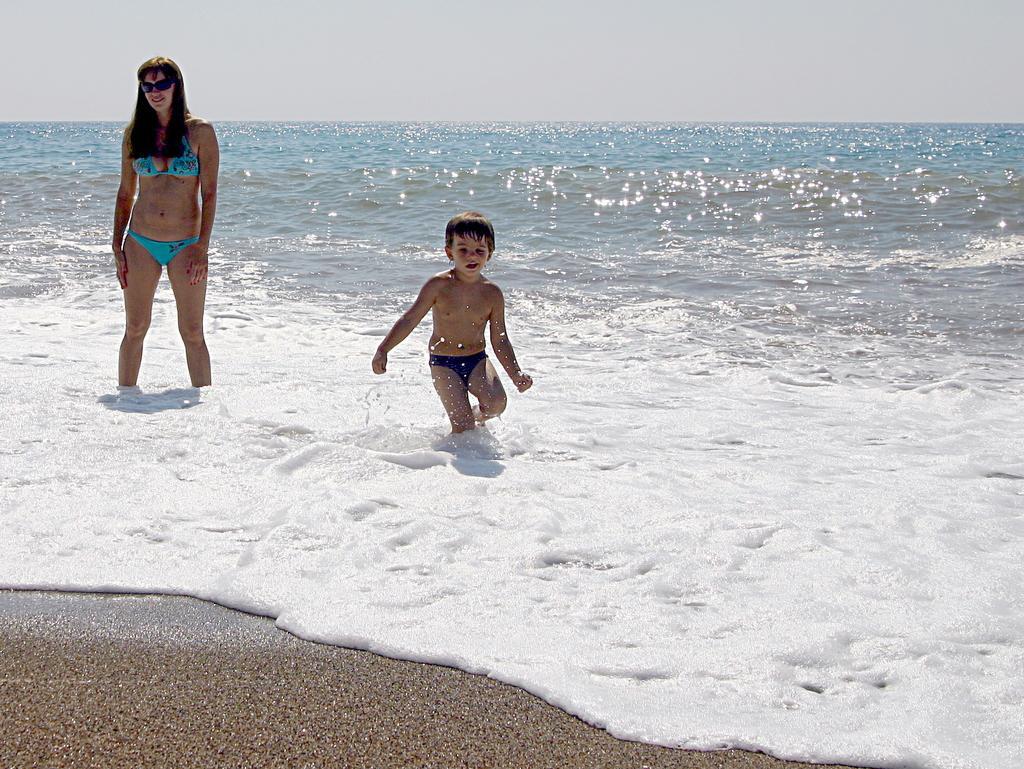Can you describe this image briefly? In this picture in the center there are persons standing in the water. In the background there is an ocean. 